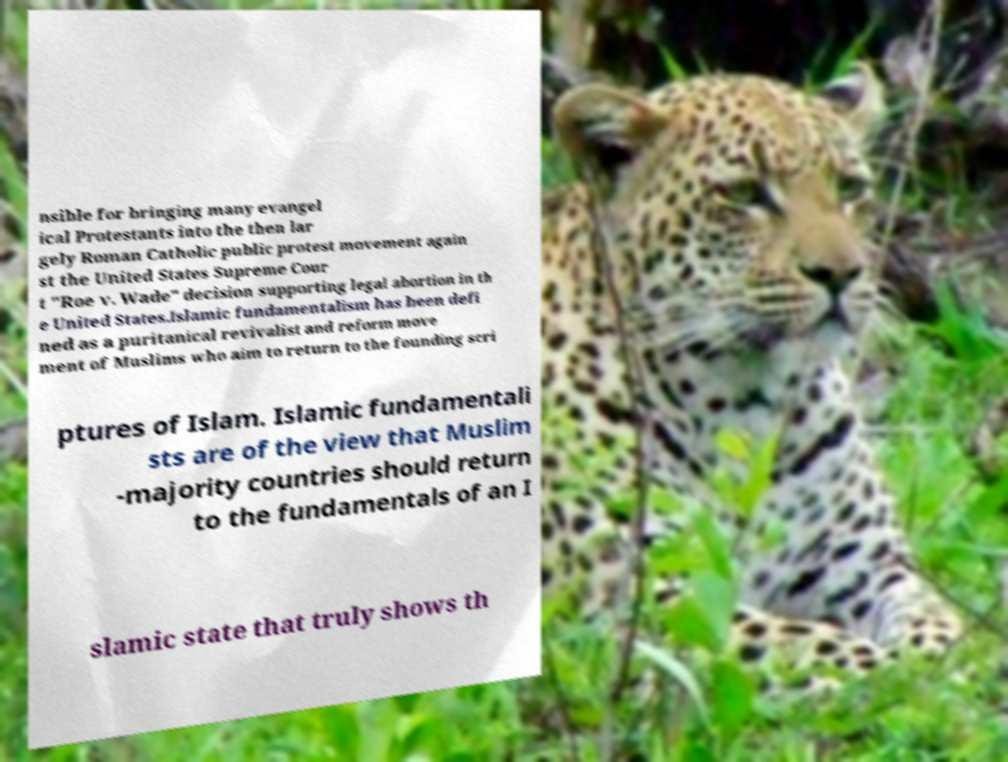Please read and relay the text visible in this image. What does it say? nsible for bringing many evangel ical Protestants into the then lar gely Roman Catholic public protest movement again st the United States Supreme Cour t "Roe v. Wade" decision supporting legal abortion in th e United States.Islamic fundamentalism has been defi ned as a puritanical revivalist and reform move ment of Muslims who aim to return to the founding scri ptures of Islam. Islamic fundamentali sts are of the view that Muslim -majority countries should return to the fundamentals of an I slamic state that truly shows th 